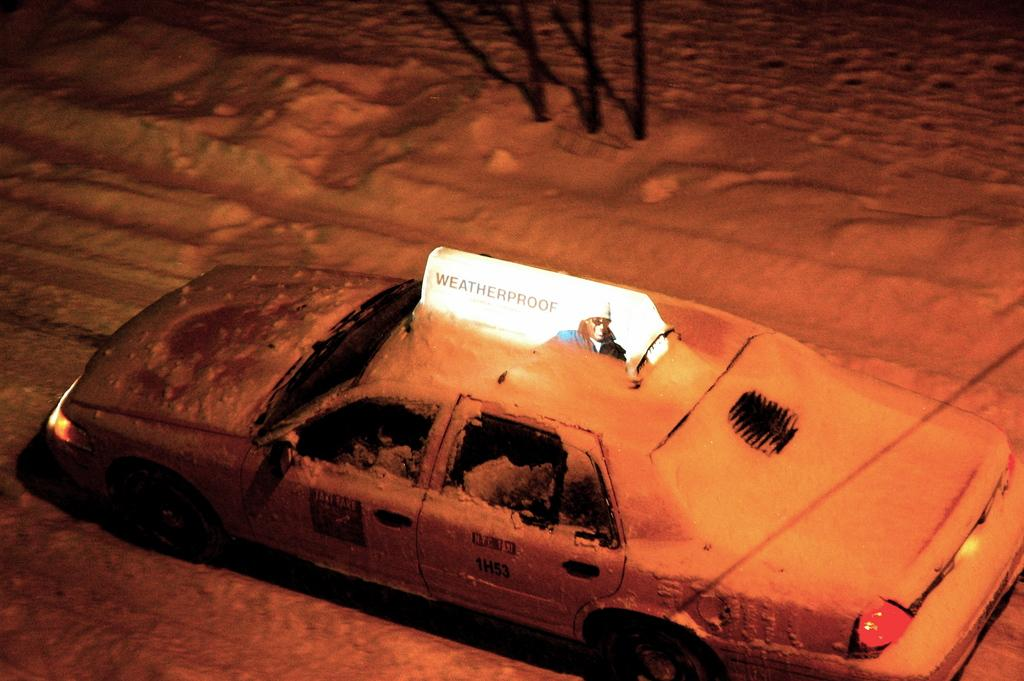<image>
Summarize the visual content of the image. A snow covered taxi with a Weatherproof advertisement on its roof 